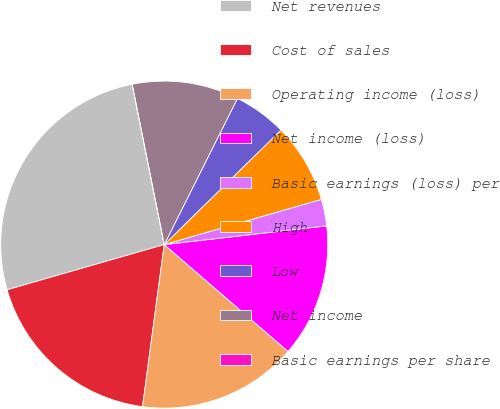<chart> <loc_0><loc_0><loc_500><loc_500><pie_chart><fcel>Net revenues<fcel>Cost of sales<fcel>Operating income (loss)<fcel>Net income (loss)<fcel>Basic earnings (loss) per<fcel>High<fcel>Low<fcel>Net income<fcel>Basic earnings per share<nl><fcel>26.32%<fcel>18.42%<fcel>15.79%<fcel>13.16%<fcel>2.63%<fcel>7.89%<fcel>5.26%<fcel>10.53%<fcel>0.0%<nl></chart> 